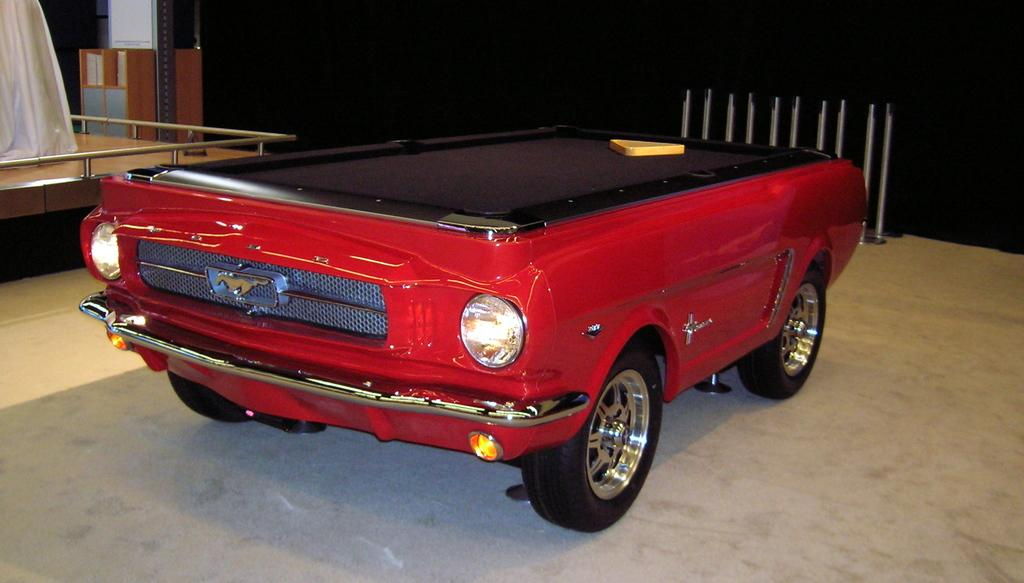What is placed on the board in the image? The facts do not specify what the object on the board is. Where is the board located? The board is on a vehicle. How is the vehicle positioned in the image? The vehicle is on the floor. What can be seen in the background of the image? There are stands, a cupboard, a pole, a stage, and a cloth in the background. What type of market can be seen in the background of the image? There is no market present in the image; the background features stands, a cupboard, a pole, a stage, and a cloth. What kind of system is responsible for the clouds in the image? There are no clouds present in the image, so it is not possible to determine what system might be responsible for them. 